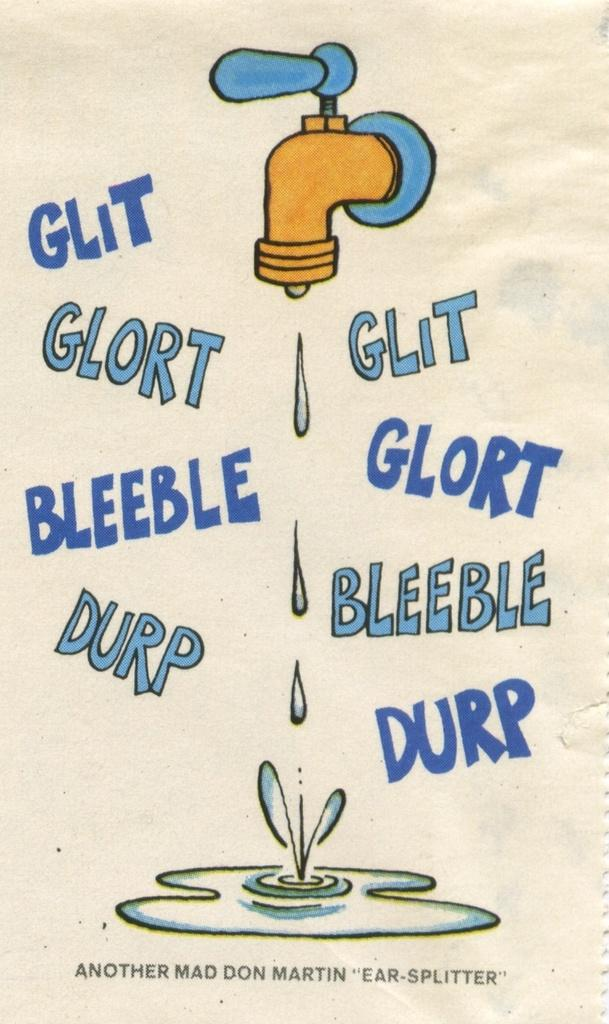<image>
Create a compact narrative representing the image presented. A faucet drips water into a puddle, below the puddle it says Another Mad Don Martin Ear Splitter. 